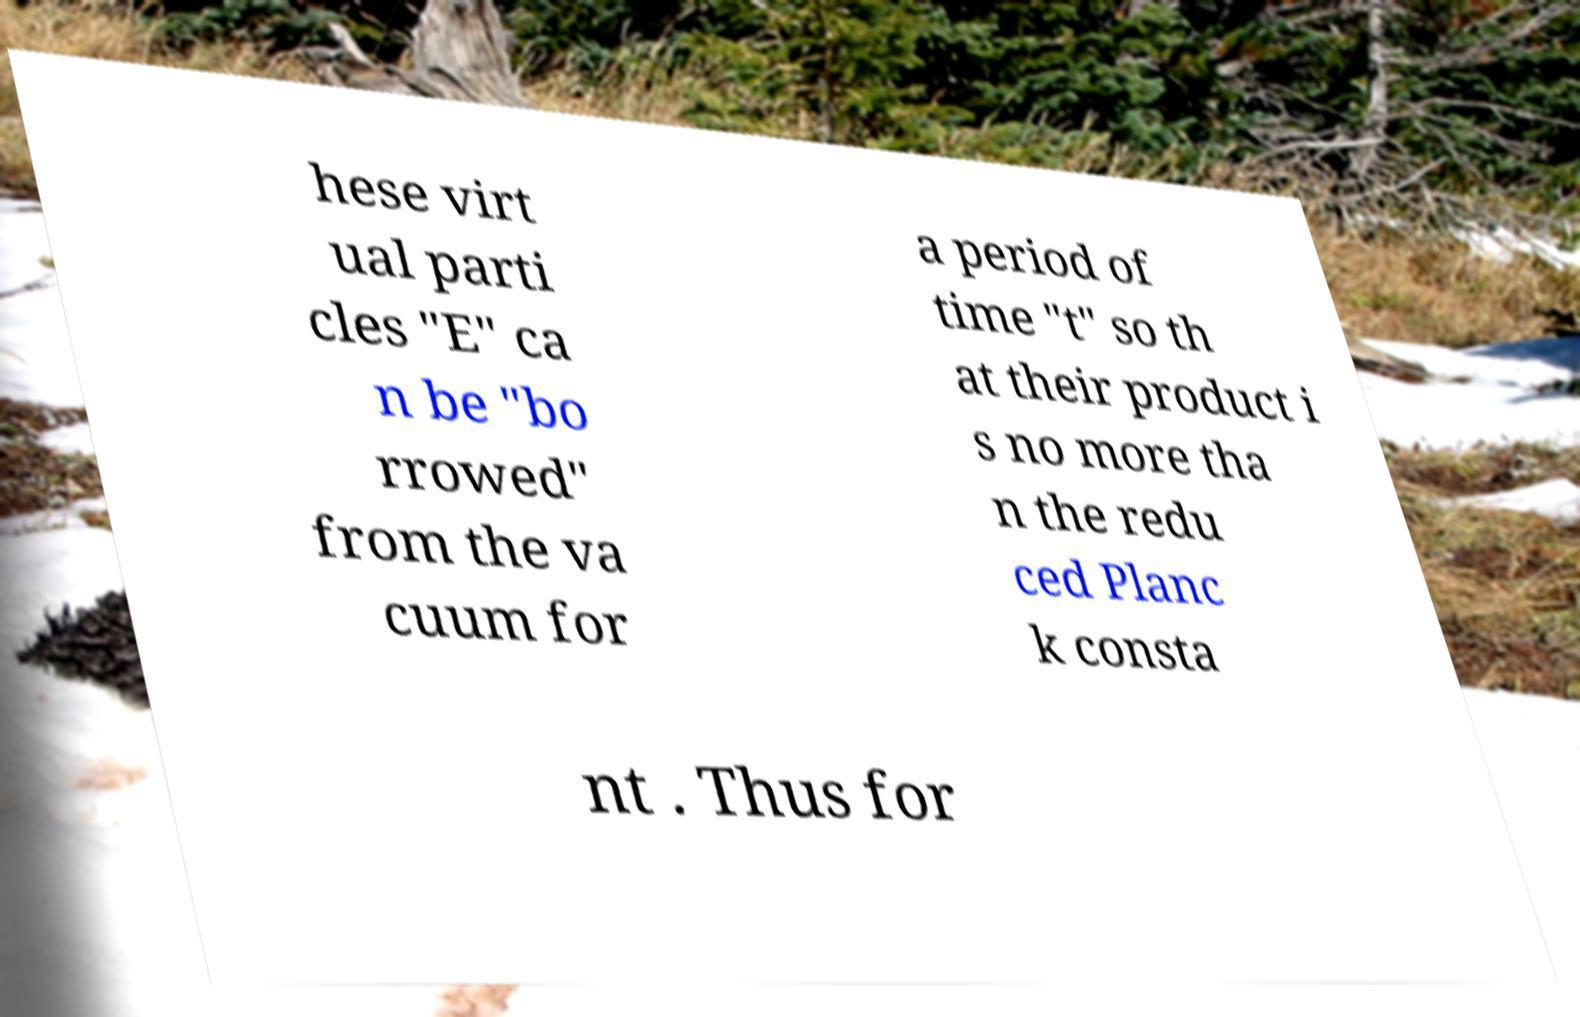What messages or text are displayed in this image? I need them in a readable, typed format. hese virt ual parti cles "E" ca n be "bo rrowed" from the va cuum for a period of time "t" so th at their product i s no more tha n the redu ced Planc k consta nt . Thus for 